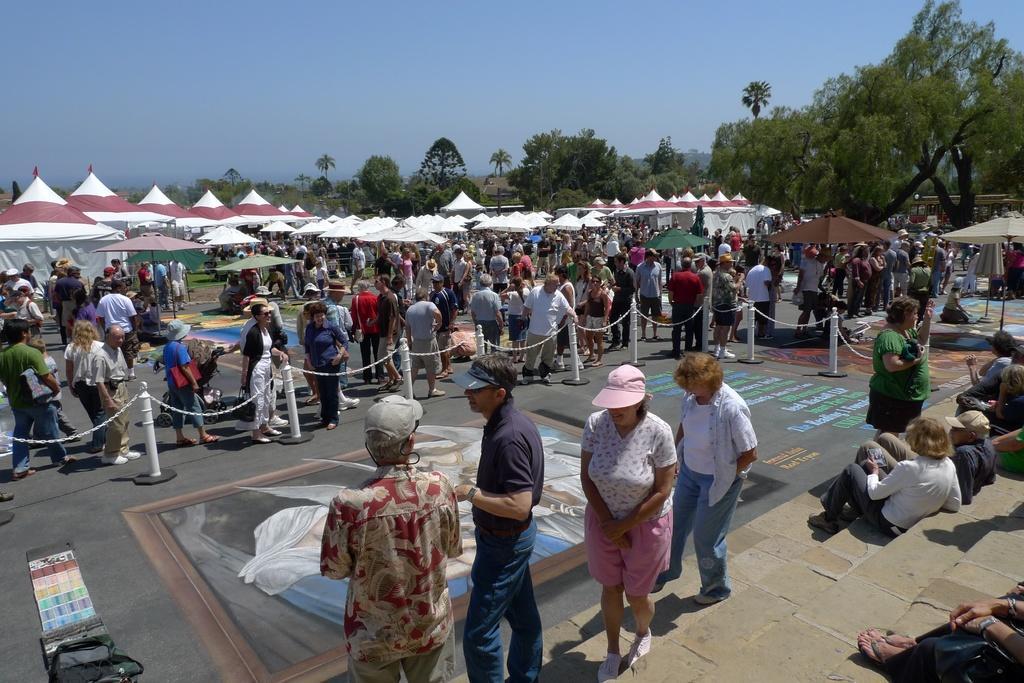Describe this image in one or two sentences. In this picture we can observe a painting on the road. There are some members standing and watching this painting. There were men and women. Some of them were sitting on the right side. We can observe white color tents. In the background there are trees and a sky. 